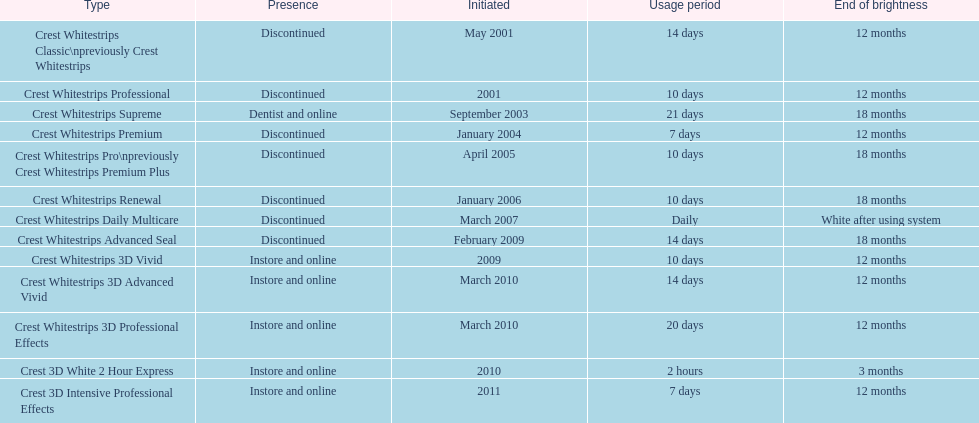Does the crest white strips classic last at least one year? Yes. 